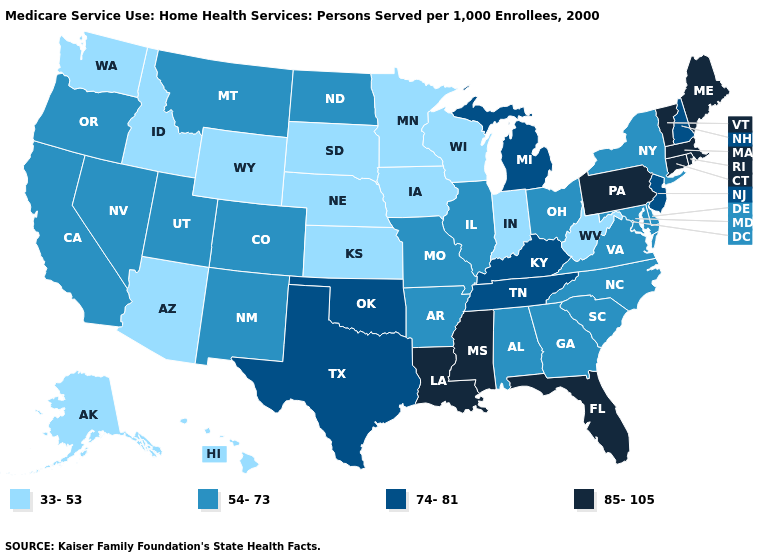Does West Virginia have the lowest value in the South?
Concise answer only. Yes. Does Oklahoma have the lowest value in the South?
Quick response, please. No. What is the value of Montana?
Short answer required. 54-73. Does the map have missing data?
Write a very short answer. No. Does the map have missing data?
Answer briefly. No. What is the value of Indiana?
Give a very brief answer. 33-53. What is the lowest value in the USA?
Write a very short answer. 33-53. Does Vermont have the highest value in the USA?
Concise answer only. Yes. Name the states that have a value in the range 74-81?
Short answer required. Kentucky, Michigan, New Hampshire, New Jersey, Oklahoma, Tennessee, Texas. What is the value of South Dakota?
Be succinct. 33-53. Name the states that have a value in the range 85-105?
Short answer required. Connecticut, Florida, Louisiana, Maine, Massachusetts, Mississippi, Pennsylvania, Rhode Island, Vermont. Among the states that border Wisconsin , does Michigan have the lowest value?
Give a very brief answer. No. What is the value of New Jersey?
Concise answer only. 74-81. Name the states that have a value in the range 85-105?
Answer briefly. Connecticut, Florida, Louisiana, Maine, Massachusetts, Mississippi, Pennsylvania, Rhode Island, Vermont. Name the states that have a value in the range 54-73?
Be succinct. Alabama, Arkansas, California, Colorado, Delaware, Georgia, Illinois, Maryland, Missouri, Montana, Nevada, New Mexico, New York, North Carolina, North Dakota, Ohio, Oregon, South Carolina, Utah, Virginia. 